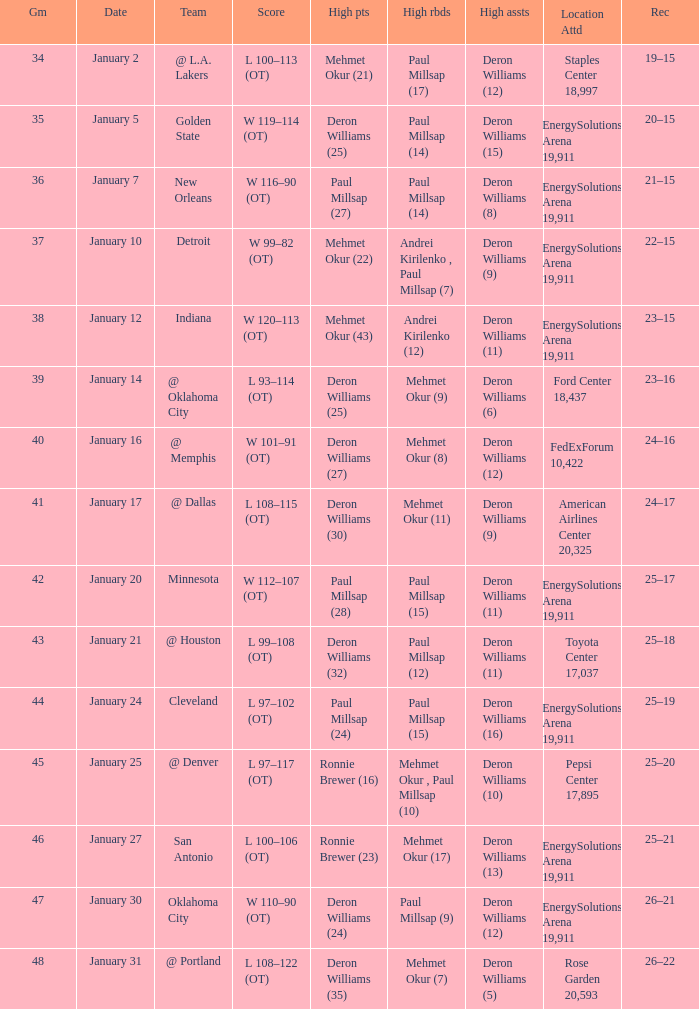Who had the high rebounds on January 24? Paul Millsap (15). 